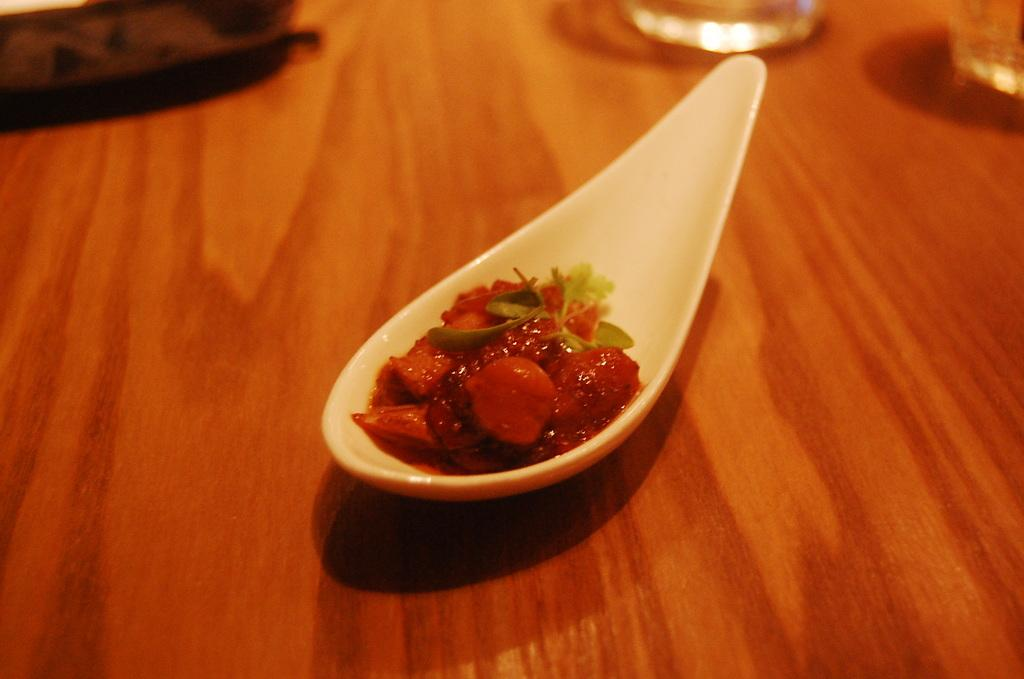What type of table is in the image? There is a wooden table in the image. What is on the table? There is a spoon with red color food items and glasses on the table. Are there any other items on the table? Yes, there are additional items on the table. What type of insect can be seen in the aftermath of the family gathering in the image? There is no insect or family gathering present in the image. 